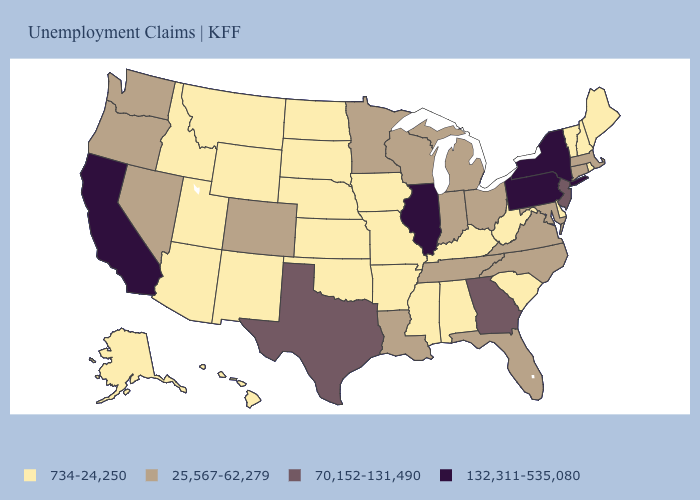Which states have the lowest value in the USA?
Quick response, please. Alabama, Alaska, Arizona, Arkansas, Delaware, Hawaii, Idaho, Iowa, Kansas, Kentucky, Maine, Mississippi, Missouri, Montana, Nebraska, New Hampshire, New Mexico, North Dakota, Oklahoma, Rhode Island, South Carolina, South Dakota, Utah, Vermont, West Virginia, Wyoming. Among the states that border Idaho , does Montana have the lowest value?
Be succinct. Yes. What is the lowest value in the USA?
Be succinct. 734-24,250. Name the states that have a value in the range 25,567-62,279?
Quick response, please. Colorado, Connecticut, Florida, Indiana, Louisiana, Maryland, Massachusetts, Michigan, Minnesota, Nevada, North Carolina, Ohio, Oregon, Tennessee, Virginia, Washington, Wisconsin. What is the lowest value in the USA?
Write a very short answer. 734-24,250. What is the value of Maryland?
Quick response, please. 25,567-62,279. Which states have the lowest value in the USA?
Keep it brief. Alabama, Alaska, Arizona, Arkansas, Delaware, Hawaii, Idaho, Iowa, Kansas, Kentucky, Maine, Mississippi, Missouri, Montana, Nebraska, New Hampshire, New Mexico, North Dakota, Oklahoma, Rhode Island, South Carolina, South Dakota, Utah, Vermont, West Virginia, Wyoming. Which states hav the highest value in the South?
Short answer required. Georgia, Texas. What is the value of New Hampshire?
Short answer required. 734-24,250. Name the states that have a value in the range 132,311-535,080?
Keep it brief. California, Illinois, New York, Pennsylvania. Is the legend a continuous bar?
Be succinct. No. What is the value of Texas?
Concise answer only. 70,152-131,490. What is the highest value in the USA?
Keep it brief. 132,311-535,080. Which states have the lowest value in the USA?
Keep it brief. Alabama, Alaska, Arizona, Arkansas, Delaware, Hawaii, Idaho, Iowa, Kansas, Kentucky, Maine, Mississippi, Missouri, Montana, Nebraska, New Hampshire, New Mexico, North Dakota, Oklahoma, Rhode Island, South Carolina, South Dakota, Utah, Vermont, West Virginia, Wyoming. What is the highest value in the USA?
Be succinct. 132,311-535,080. 